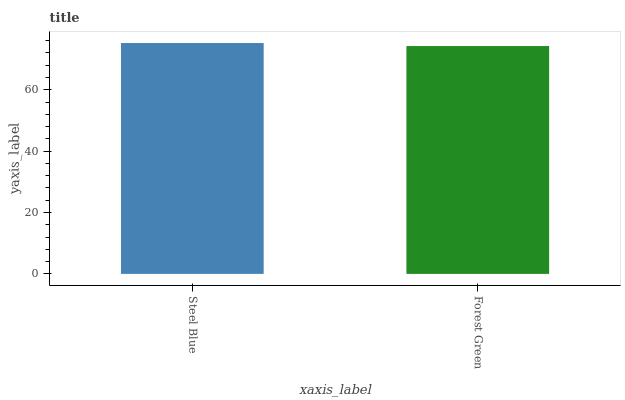Is Forest Green the minimum?
Answer yes or no. Yes. Is Steel Blue the maximum?
Answer yes or no. Yes. Is Forest Green the maximum?
Answer yes or no. No. Is Steel Blue greater than Forest Green?
Answer yes or no. Yes. Is Forest Green less than Steel Blue?
Answer yes or no. Yes. Is Forest Green greater than Steel Blue?
Answer yes or no. No. Is Steel Blue less than Forest Green?
Answer yes or no. No. Is Steel Blue the high median?
Answer yes or no. Yes. Is Forest Green the low median?
Answer yes or no. Yes. Is Forest Green the high median?
Answer yes or no. No. Is Steel Blue the low median?
Answer yes or no. No. 